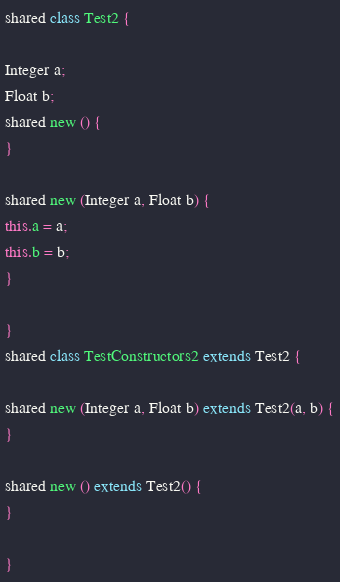<code> <loc_0><loc_0><loc_500><loc_500><_Ceylon_>shared class Test2 {

Integer a;
Float b;
shared new () {
}

shared new (Integer a, Float b) {
this.a = a;
this.b = b;
}

}
shared class TestConstructors2 extends Test2 {

shared new (Integer a, Float b) extends Test2(a, b) {
}

shared new () extends Test2() {
}

}
</code> 